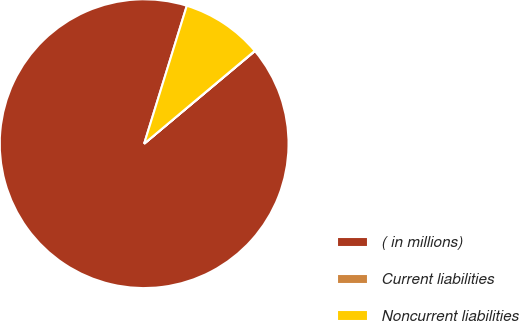Convert chart to OTSL. <chart><loc_0><loc_0><loc_500><loc_500><pie_chart><fcel>( in millions)<fcel>Current liabilities<fcel>Noncurrent liabilities<nl><fcel>90.85%<fcel>0.03%<fcel>9.11%<nl></chart> 